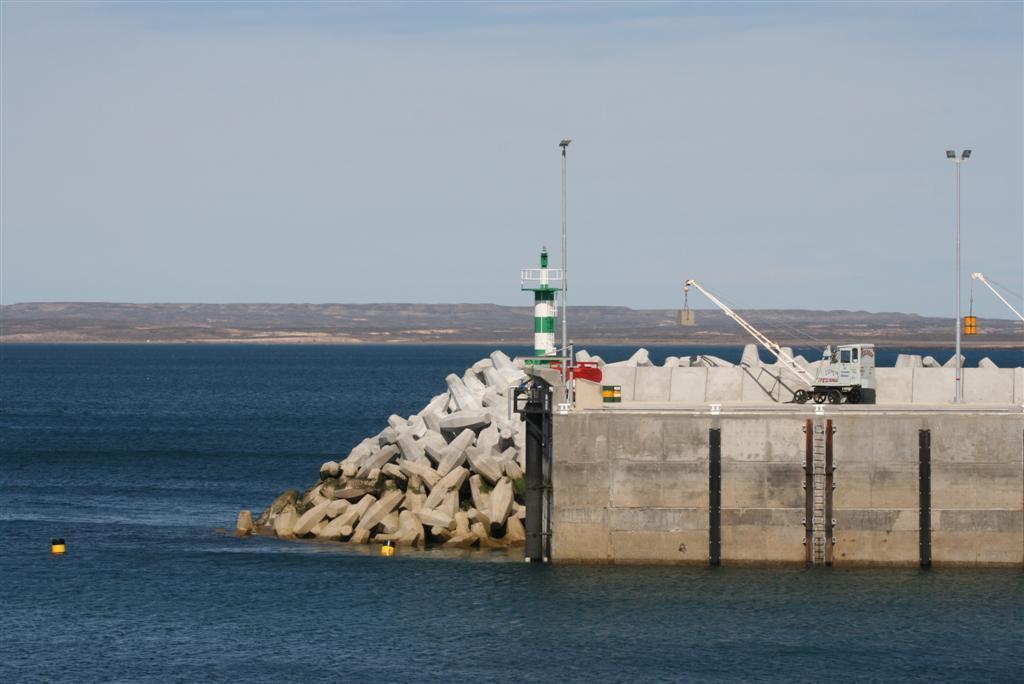Can you describe this image briefly? In the foreground I can see a fence, stones, tower, poles and a vehicle. In the background I can see water, mountains and the sky. This image is taken may be in the ocean. 